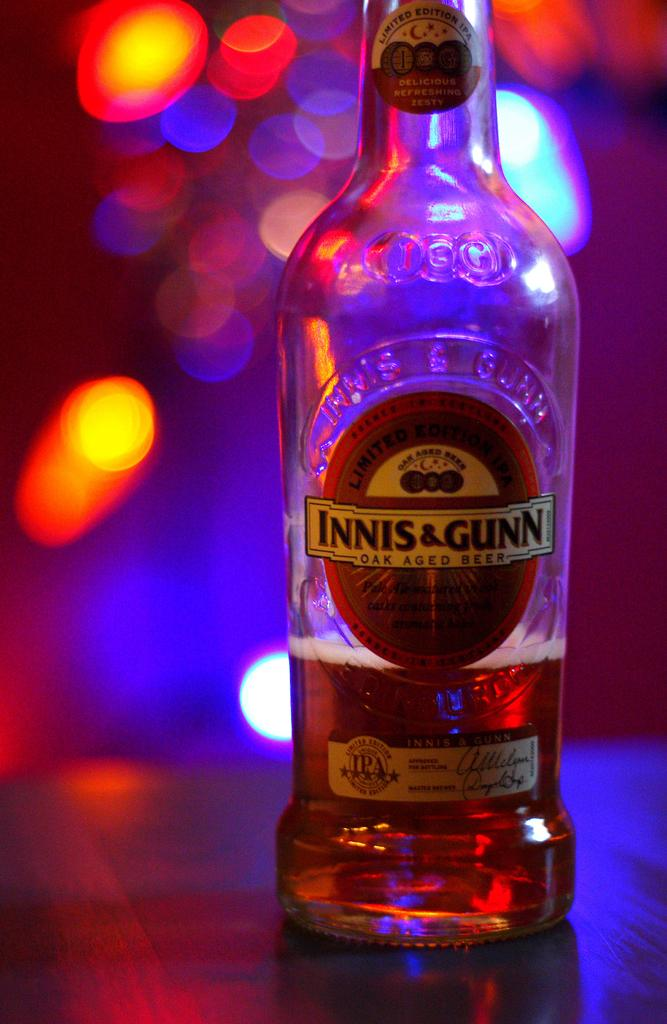What is on the table in the image? There is a bottle with a label on the table in the image. Can you describe the bottle's appearance? The bottle has a label on it. What can be seen in the background of the image? There are multi-color lights in the background of the image. What word is the tiger trying to spell out using its digestive system in the image? There is no tiger or word present in the image, and the tiger's digestive system is not mentioned. 